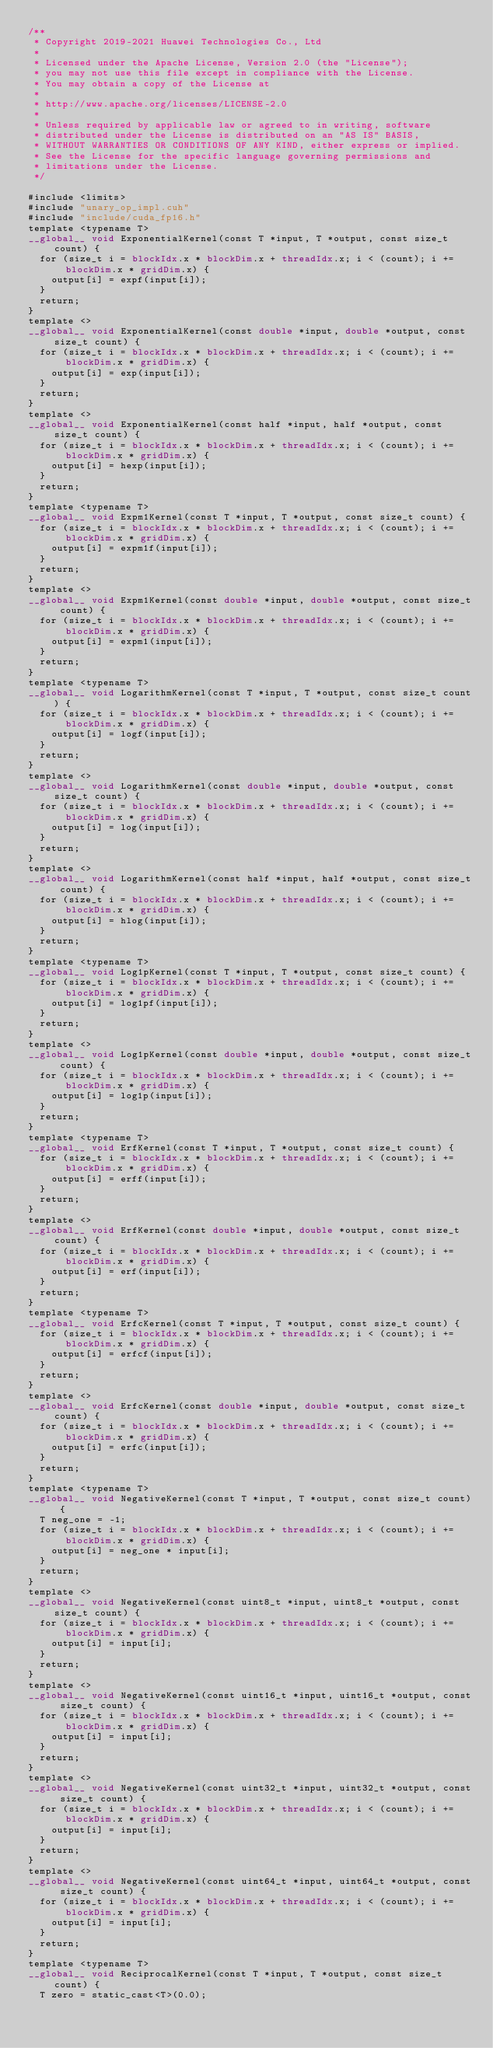Convert code to text. <code><loc_0><loc_0><loc_500><loc_500><_Cuda_>/**
 * Copyright 2019-2021 Huawei Technologies Co., Ltd
 *
 * Licensed under the Apache License, Version 2.0 (the "License");
 * you may not use this file except in compliance with the License.
 * You may obtain a copy of the License at
 *
 * http://www.apache.org/licenses/LICENSE-2.0
 *
 * Unless required by applicable law or agreed to in writing, software
 * distributed under the License is distributed on an "AS IS" BASIS,
 * WITHOUT WARRANTIES OR CONDITIONS OF ANY KIND, either express or implied.
 * See the License for the specific language governing permissions and
 * limitations under the License.
 */

#include <limits>
#include "unary_op_impl.cuh"
#include "include/cuda_fp16.h"
template <typename T>
__global__ void ExponentialKernel(const T *input, T *output, const size_t count) {
  for (size_t i = blockIdx.x * blockDim.x + threadIdx.x; i < (count); i += blockDim.x * gridDim.x) {
    output[i] = expf(input[i]);
  }
  return;
}
template <>
__global__ void ExponentialKernel(const double *input, double *output, const size_t count) {
  for (size_t i = blockIdx.x * blockDim.x + threadIdx.x; i < (count); i += blockDim.x * gridDim.x) {
    output[i] = exp(input[i]);
  }
  return;
}
template <>
__global__ void ExponentialKernel(const half *input, half *output, const size_t count) {
  for (size_t i = blockIdx.x * blockDim.x + threadIdx.x; i < (count); i += blockDim.x * gridDim.x) {
    output[i] = hexp(input[i]);
  }
  return;
}
template <typename T>
__global__ void Expm1Kernel(const T *input, T *output, const size_t count) {
  for (size_t i = blockIdx.x * blockDim.x + threadIdx.x; i < (count); i += blockDim.x * gridDim.x) {
    output[i] = expm1f(input[i]);
  }
  return;
}
template <>
__global__ void Expm1Kernel(const double *input, double *output, const size_t count) {
  for (size_t i = blockIdx.x * blockDim.x + threadIdx.x; i < (count); i += blockDim.x * gridDim.x) {
    output[i] = expm1(input[i]);
  }
  return;
}
template <typename T>
__global__ void LogarithmKernel(const T *input, T *output, const size_t count) {
  for (size_t i = blockIdx.x * blockDim.x + threadIdx.x; i < (count); i += blockDim.x * gridDim.x) {
    output[i] = logf(input[i]);
  }
  return;
}
template <>
__global__ void LogarithmKernel(const double *input, double *output, const size_t count) {
  for (size_t i = blockIdx.x * blockDim.x + threadIdx.x; i < (count); i += blockDim.x * gridDim.x) {
    output[i] = log(input[i]);
  }
  return;
}
template <>
__global__ void LogarithmKernel(const half *input, half *output, const size_t count) {
  for (size_t i = blockIdx.x * blockDim.x + threadIdx.x; i < (count); i += blockDim.x * gridDim.x) {
    output[i] = hlog(input[i]);
  }
  return;
}
template <typename T>
__global__ void Log1pKernel(const T *input, T *output, const size_t count) {
  for (size_t i = blockIdx.x * blockDim.x + threadIdx.x; i < (count); i += blockDim.x * gridDim.x) {
    output[i] = log1pf(input[i]);
  }
  return;
}
template <>
__global__ void Log1pKernel(const double *input, double *output, const size_t count) {
  for (size_t i = blockIdx.x * blockDim.x + threadIdx.x; i < (count); i += blockDim.x * gridDim.x) {
    output[i] = log1p(input[i]);
  }
  return;
}
template <typename T>
__global__ void ErfKernel(const T *input, T *output, const size_t count) {
  for (size_t i = blockIdx.x * blockDim.x + threadIdx.x; i < (count); i += blockDim.x * gridDim.x) {
    output[i] = erff(input[i]);
  }
  return;
}
template <>
__global__ void ErfKernel(const double *input, double *output, const size_t count) {
  for (size_t i = blockIdx.x * blockDim.x + threadIdx.x; i < (count); i += blockDim.x * gridDim.x) {
    output[i] = erf(input[i]);
  }
  return;
}
template <typename T>
__global__ void ErfcKernel(const T *input, T *output, const size_t count) {
  for (size_t i = blockIdx.x * blockDim.x + threadIdx.x; i < (count); i += blockDim.x * gridDim.x) {
    output[i] = erfcf(input[i]);
  }
  return;
}
template <>
__global__ void ErfcKernel(const double *input, double *output, const size_t count) {
  for (size_t i = blockIdx.x * blockDim.x + threadIdx.x; i < (count); i += blockDim.x * gridDim.x) {
    output[i] = erfc(input[i]);
  }
  return;
}
template <typename T>
__global__ void NegativeKernel(const T *input, T *output, const size_t count) {
  T neg_one = -1;
  for (size_t i = blockIdx.x * blockDim.x + threadIdx.x; i < (count); i += blockDim.x * gridDim.x) {
    output[i] = neg_one * input[i];
  }
  return;
}
template <>
__global__ void NegativeKernel(const uint8_t *input, uint8_t *output, const size_t count) {
  for (size_t i = blockIdx.x * blockDim.x + threadIdx.x; i < (count); i += blockDim.x * gridDim.x) {
    output[i] = input[i];
  }
  return;
}
template <>
__global__ void NegativeKernel(const uint16_t *input, uint16_t *output, const size_t count) {
  for (size_t i = blockIdx.x * blockDim.x + threadIdx.x; i < (count); i += blockDim.x * gridDim.x) {
    output[i] = input[i];
  }
  return;
}
template <>
__global__ void NegativeKernel(const uint32_t *input, uint32_t *output, const size_t count) {
  for (size_t i = blockIdx.x * blockDim.x + threadIdx.x; i < (count); i += blockDim.x * gridDim.x) {
    output[i] = input[i];
  }
  return;
}
template <>
__global__ void NegativeKernel(const uint64_t *input, uint64_t *output, const size_t count) {
  for (size_t i = blockIdx.x * blockDim.x + threadIdx.x; i < (count); i += blockDim.x * gridDim.x) {
    output[i] = input[i];
  }
  return;
}
template <typename T>
__global__ void ReciprocalKernel(const T *input, T *output, const size_t count) {
  T zero = static_cast<T>(0.0);</code> 